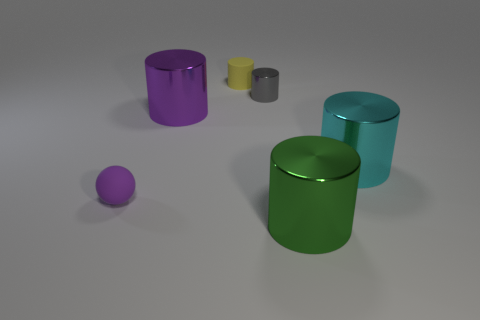What number of other things are the same size as the yellow rubber object?
Your answer should be compact. 2. What is the material of the cylinder that is both to the right of the gray metal thing and behind the green cylinder?
Provide a succinct answer. Metal. Does the matte cylinder have the same color as the large shiny object that is to the left of the yellow rubber cylinder?
Your response must be concise. No. The purple thing that is the same shape as the large cyan metal thing is what size?
Offer a very short reply. Large. The metallic object that is both in front of the tiny metallic thing and on the left side of the green cylinder has what shape?
Offer a terse response. Cylinder. Does the green metallic thing have the same size as the metal cylinder that is on the left side of the small gray shiny cylinder?
Ensure brevity in your answer.  Yes. What is the color of the rubber object that is the same shape as the large cyan metal thing?
Offer a terse response. Yellow. Do the shiny thing that is left of the tiny rubber cylinder and the purple rubber object that is to the left of the tiny metal object have the same size?
Offer a terse response. No. Does the purple metal thing have the same shape as the tiny yellow thing?
Your answer should be compact. Yes. What number of objects are either small gray metal cylinders that are on the right side of the small sphere or gray cylinders?
Ensure brevity in your answer.  1. 